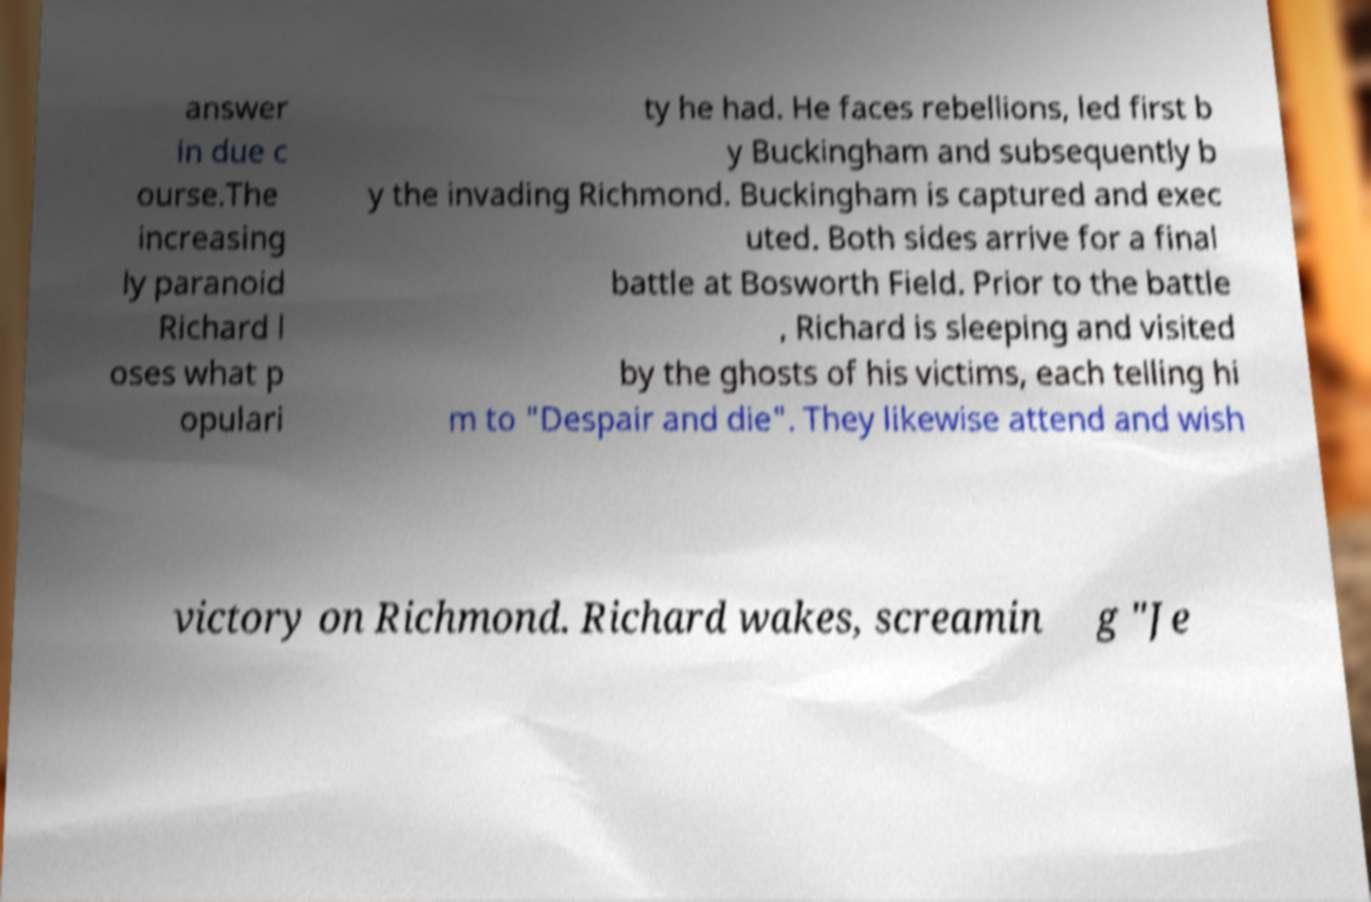Could you assist in decoding the text presented in this image and type it out clearly? answer in due c ourse.The increasing ly paranoid Richard l oses what p opulari ty he had. He faces rebellions, led first b y Buckingham and subsequently b y the invading Richmond. Buckingham is captured and exec uted. Both sides arrive for a final battle at Bosworth Field. Prior to the battle , Richard is sleeping and visited by the ghosts of his victims, each telling hi m to "Despair and die". They likewise attend and wish victory on Richmond. Richard wakes, screamin g "Je 